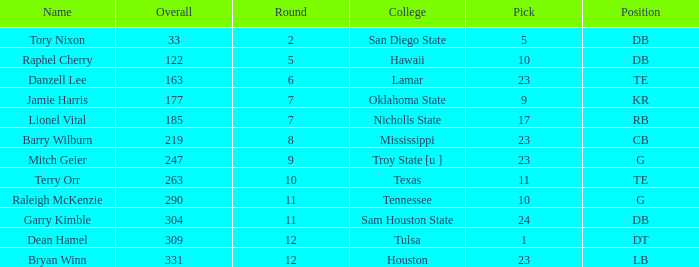How many Picks have an Overall smaller than 304, and a Position of g, and a Round smaller than 11? 1.0. 